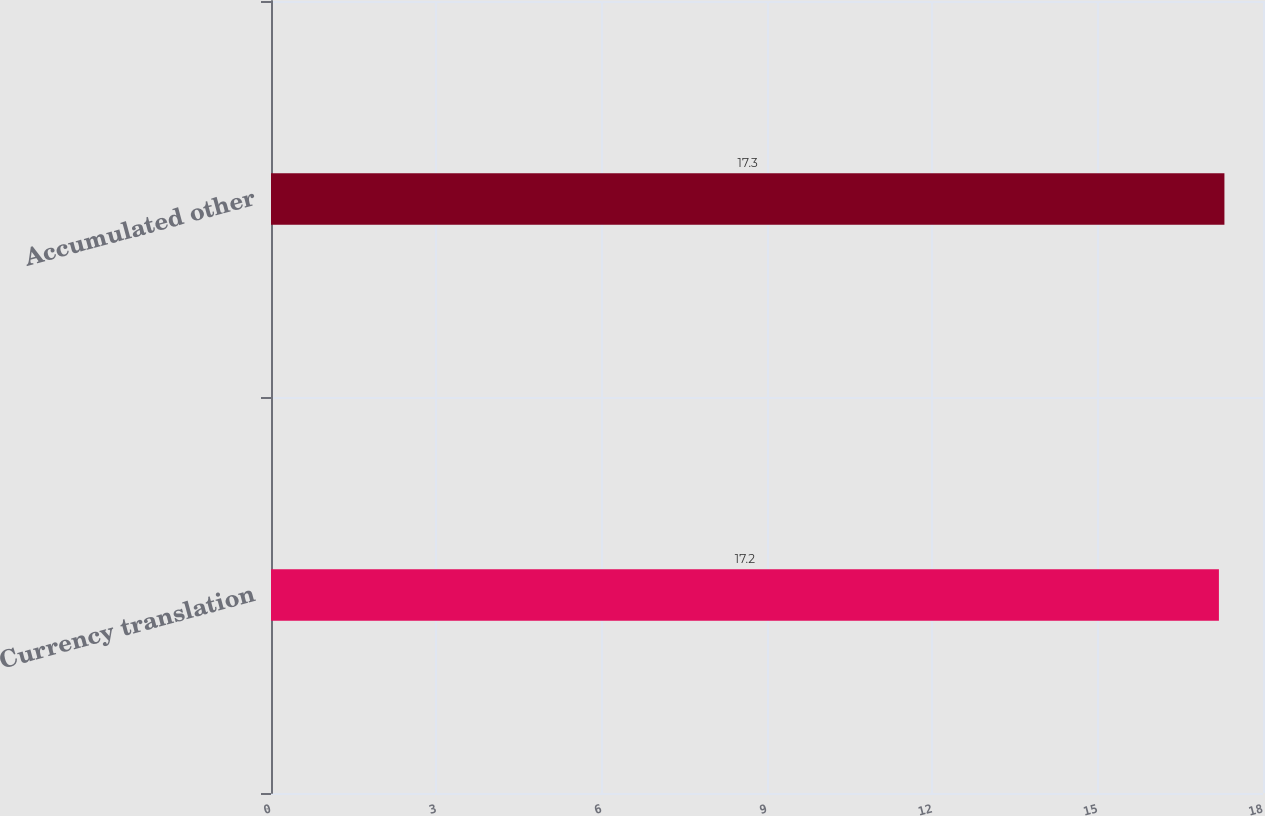Convert chart to OTSL. <chart><loc_0><loc_0><loc_500><loc_500><bar_chart><fcel>Currency translation<fcel>Accumulated other<nl><fcel>17.2<fcel>17.3<nl></chart> 